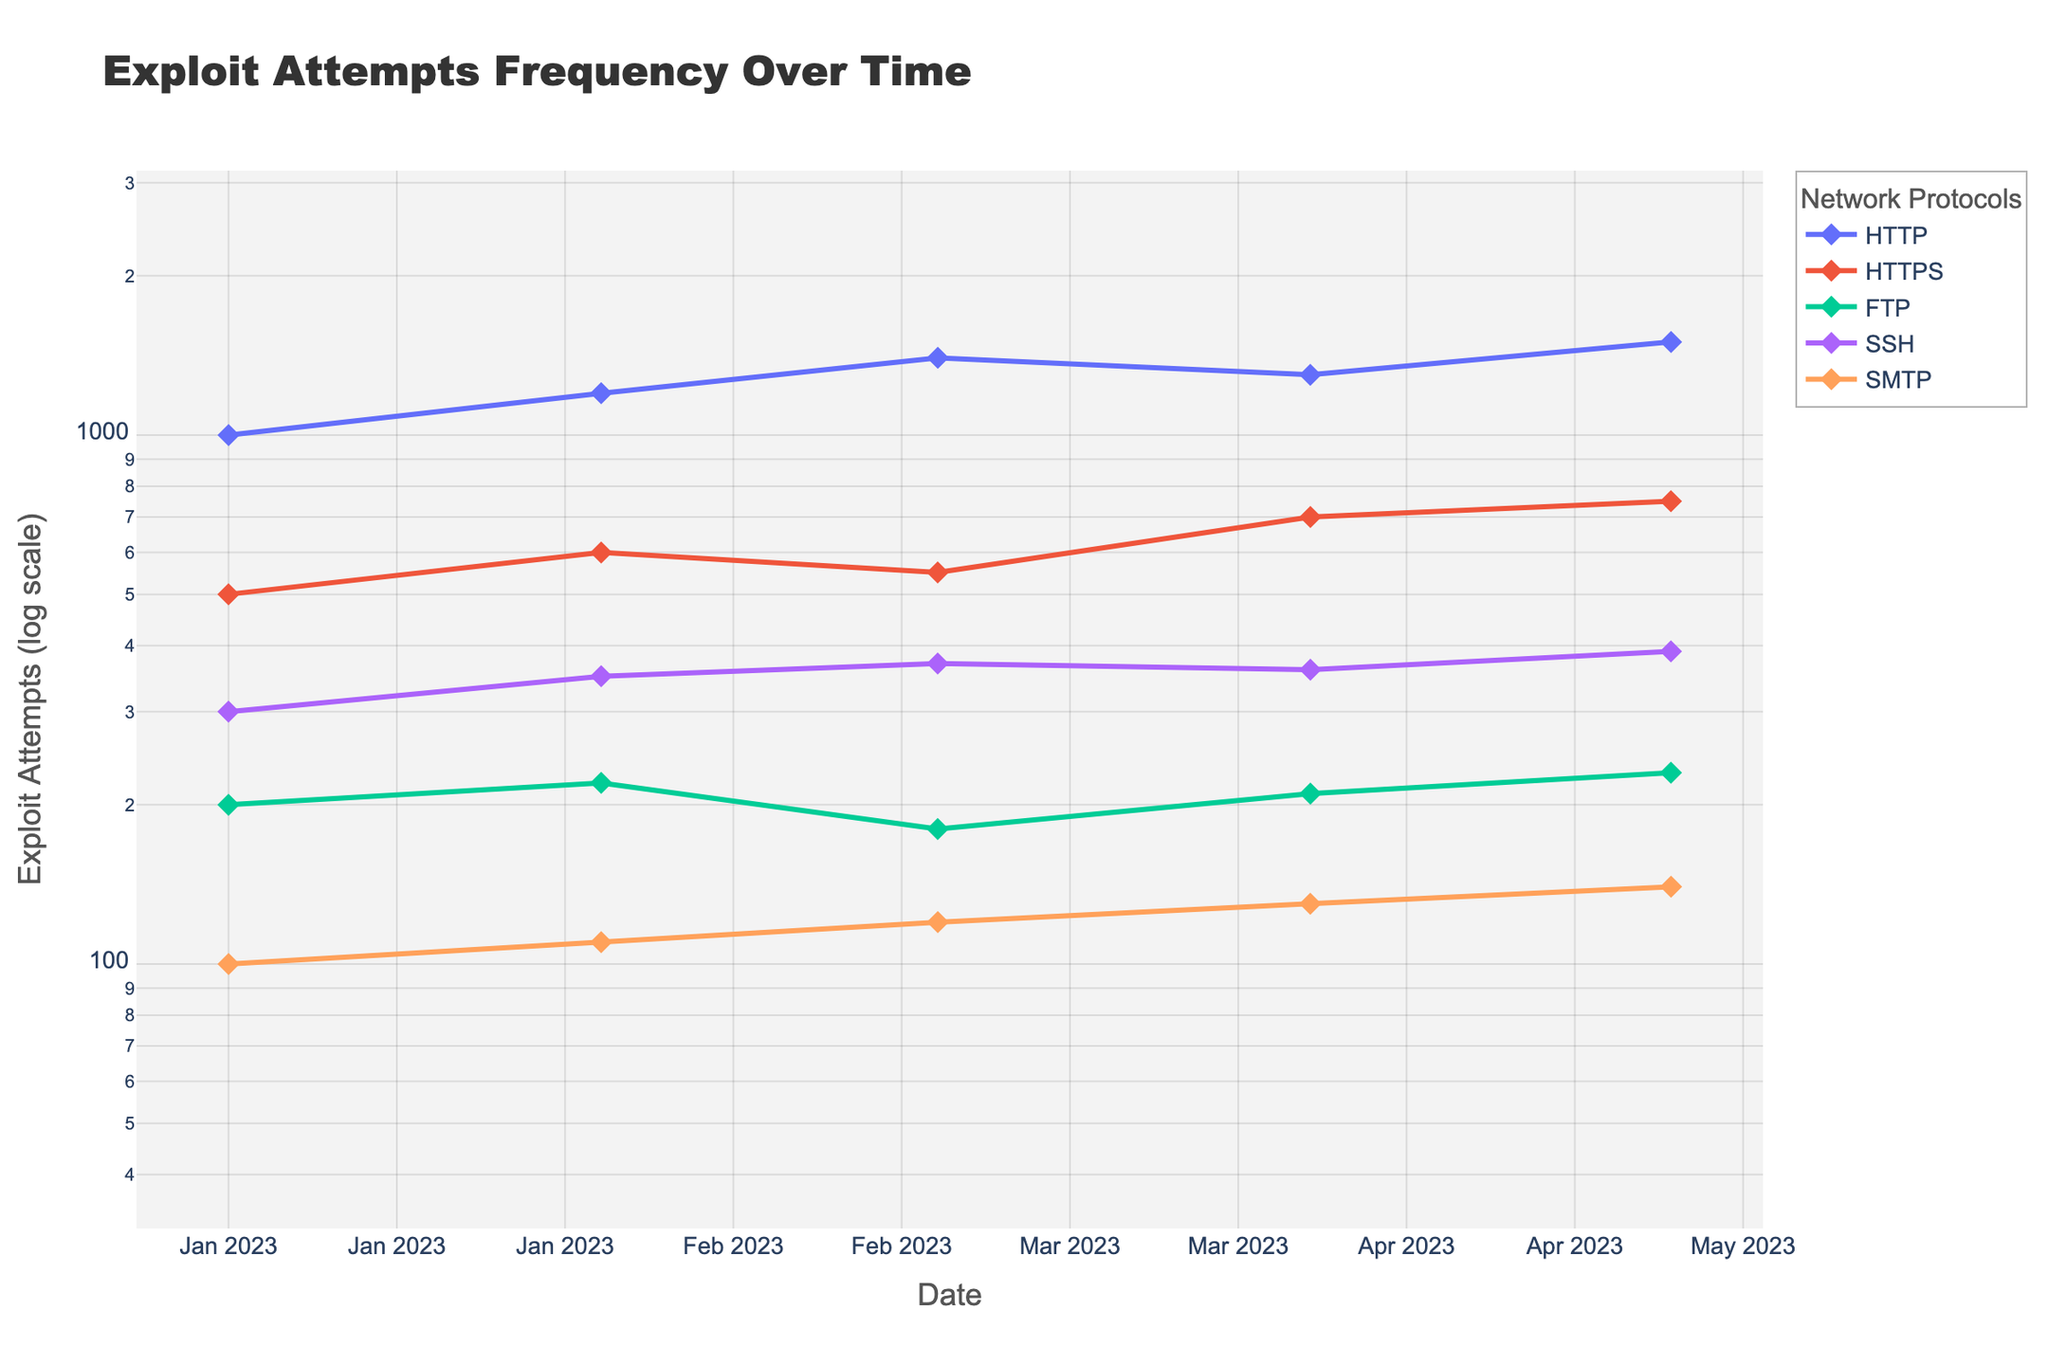What is the title of the plot? The title is displayed prominently at the top of the figure and provides a general idea of what the plot is about. In this case, the plot's title is "Exploit Attempts Frequency Over Time" as described in the code provided.
Answer: Exploit Attempts Frequency Over Time Which network protocol had the highest number of exploit attempts on May 2023? To find the highest number of exploit attempts for each protocol in May 2023, you need to look at the May 2023 data points for all the protocols and identify the maximum. HTTP has 1500, HTTPS has 750, FTP has 230, SSH has 390, and SMTP has 140. HTTP has the highest number.
Answer: HTTP Which month observed a decrease in exploit attempts for HTTP compared to the previous month? By examining the plot lines for HTTP, you can see that there is a decrease in the number of exploit attempts from March 2023 (1400) to April 2023 (1300). Hence, April 2023 observed a decrease compared to March 2023.
Answer: April 2023 Between which two months did HTTPS see the highest increase in exploit attempts? Looking at the plot for HTTPS, the number of exploit attempts increased from 550 in March 2023 to 700 in April 2023. The difference is 150, which is the highest increase compared to other months.
Answer: March 2023 and April 2023 What is the general trend of exploit attempts for FTP from January to May 2023? To observe the trend of exploit attempts for FTP, look at the plotted points and the line connecting them from January to May 2023. The values show a minor fluctuation but generally increase: 200 (Jan), 220 (Feb), 180 (Mar), 210 (Apr), 230 (May).
Answer: Generally increasing How does the trend of SSH exploit attempts compare to that of SMTP over the entire period? Compare the lines representing SSH and SMTP in the plot from January to May 2023. SSH constantly increases from 300 to 390, whereas SMTP also consistently increases but remains at a lower level from 100 to 140. Both show upward trends, but SSH had higher values.
Answer: Both increased, but SSH had higher values What is the log-scale y-coordinate range in the plot? The y-axis in the plot is set to a log scale. The code specifies the range of the log scale to be from 1.5 to 3.5. This range is seen on the y-axis to accommodate the differences in exploit attempts across protocols effectively.
Answer: 1.5 to 3.5 Compare the exploit attempt trends for HTTP and FTP. Which protocol shows a steeper increase in attempts? By examining the plot lines over time for HTTP and FTP, HTTP shows a steeper increase in exploit attempts, going from 1000 to 1500, whereas FTP remains significantly lower, increasing lightly from 200 to 230.
Answer: HTTP What can you infer about the safety of HTTPS compared to other protocols from this plot? HTTPS has fewer exploit attempts compared to HTTP but is significantly higher than FTP and SMTP. SSH also has fewer attempts than HTTPS. Hence, HTTPS is relatively safer than HTTP but not the safest compared to FTP and SMTP.
Answer: Relatively safer than HTTP Which two protocols have the closest number of exploit attempts in April 2023, and what are the numbers? By looking at the April 2023 points, HTTPS has 700, FTP has 210, SSH has 360, SMTP has 130. HTTP has 1300. SSH (360) and FTP (210) are the closest, with a difference of 150.
Answer: SSH (360) and FTP (210) 